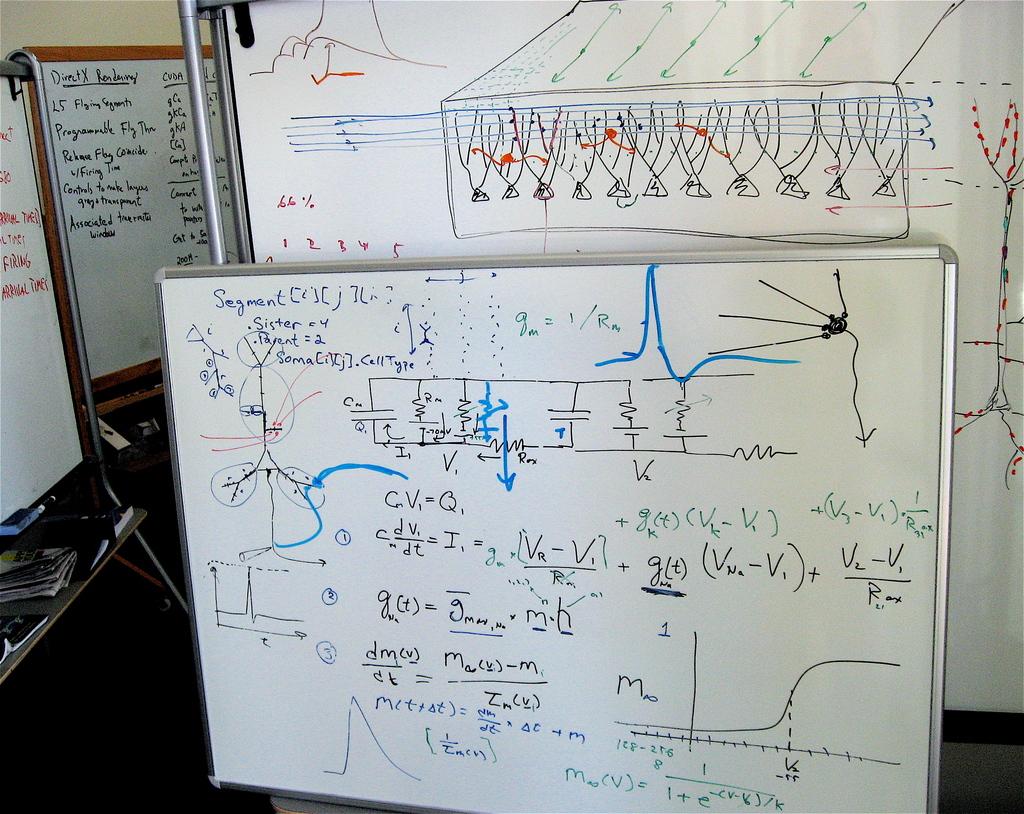What number is sister equal to?
Your response must be concise. 4. 